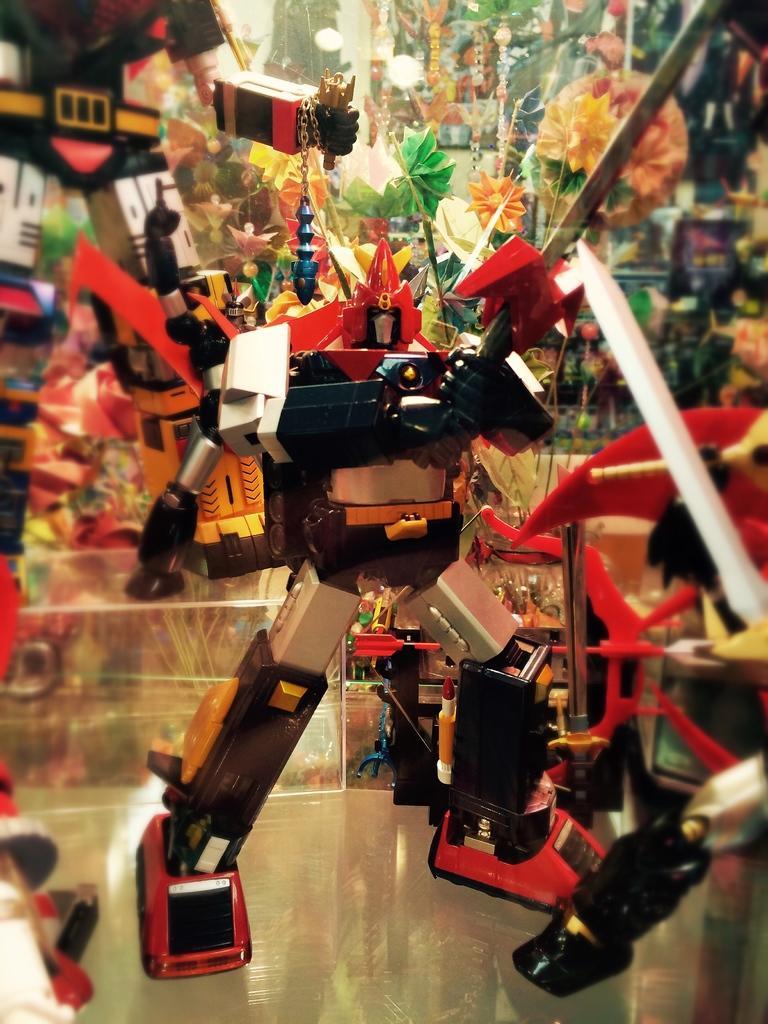In one or two sentences, can you explain what this image depicts? Here I can see a toy robot on a glass. Around this I can see some colorful toys. 